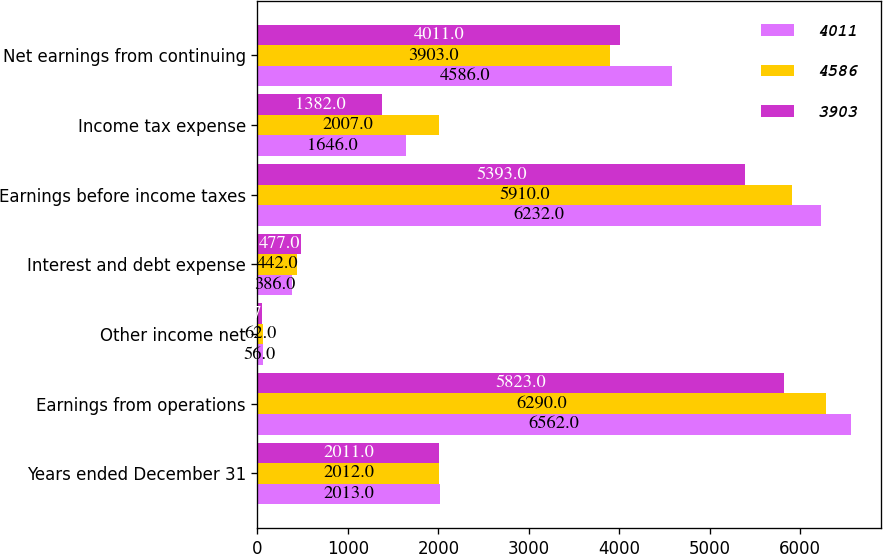Convert chart to OTSL. <chart><loc_0><loc_0><loc_500><loc_500><stacked_bar_chart><ecel><fcel>Years ended December 31<fcel>Earnings from operations<fcel>Other income net<fcel>Interest and debt expense<fcel>Earnings before income taxes<fcel>Income tax expense<fcel>Net earnings from continuing<nl><fcel>4011<fcel>2013<fcel>6562<fcel>56<fcel>386<fcel>6232<fcel>1646<fcel>4586<nl><fcel>4586<fcel>2012<fcel>6290<fcel>62<fcel>442<fcel>5910<fcel>2007<fcel>3903<nl><fcel>3903<fcel>2011<fcel>5823<fcel>47<fcel>477<fcel>5393<fcel>1382<fcel>4011<nl></chart> 